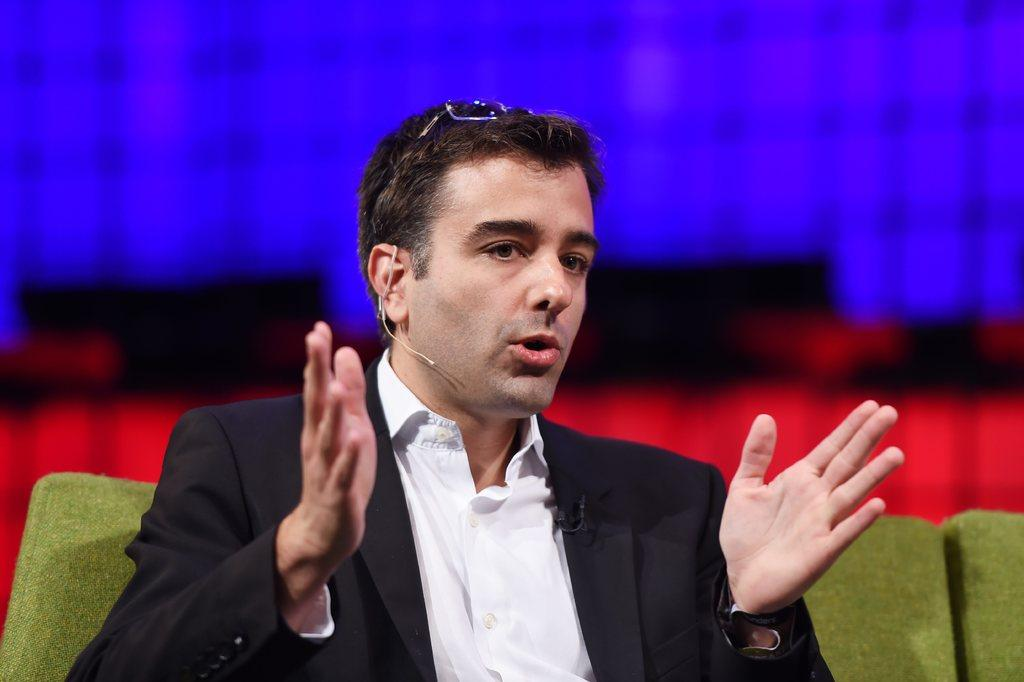What is the main subject of the image? There is a person in the image. What is the person doing in the image? The person is talking and seeing. How would you describe the background of the image? The background of the image has a blurry view. What colors are present in the image? The image contains blue and red colors. Can you identify any specific objects in the image based on their color? Yes, there is a green color object in the image. What type of bells can be heard ringing in the image? There are no bells present in the image, and therefore no sounds can be heard. How many pizzas are being eaten by the person in the image? There is no indication of pizzas in the image, so it cannot be determined. 